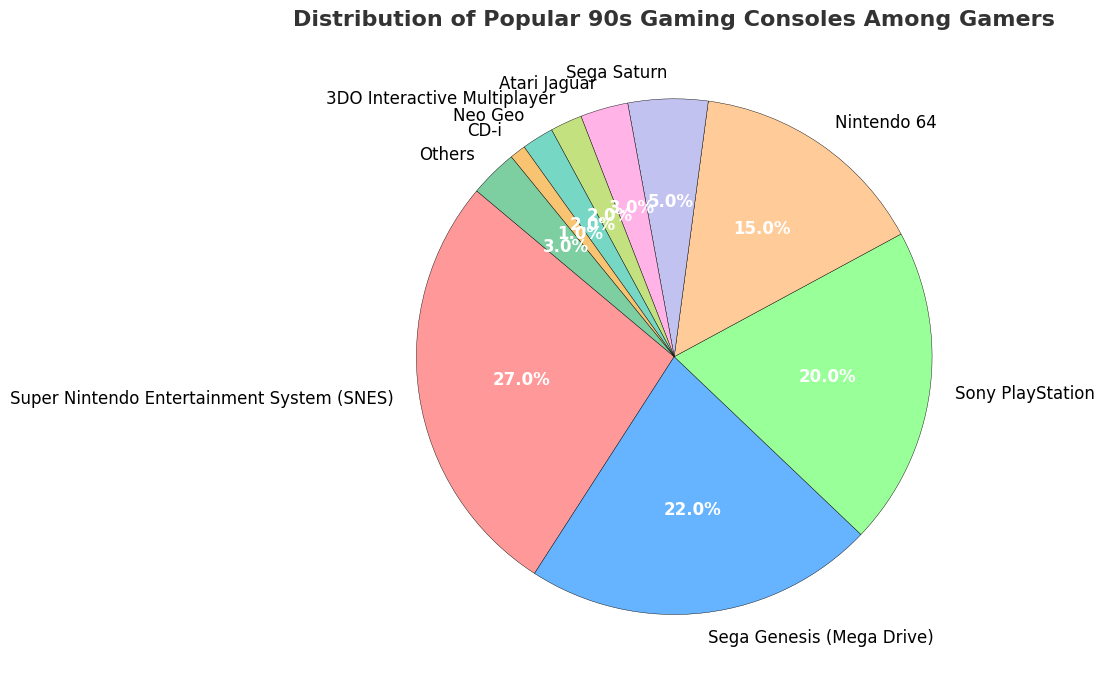Which console has the largest share among gamers? To determine the console with the largest share, look at the percentages on the pie chart; the SNES has the highest at 27%.
Answer: Super Nintendo Entertainment System (SNES) Which console has the smallest share among gamers? From the pie chart, identify the smallest segment by percentage, which is the CD-i at 1%.
Answer: CD-i How many consoles make up less than 5% each of the total distribution? Look for segments with less than 5% in the pie chart: Sega Saturn (5%), Atari Jaguar (3%), 3DO Interactive Multiplayer (2%), Neo Geo (2%), CD-i (1%), and Others (3%) which include 4 consoles.
Answer: 5 consoles Combine the shares of Sega Genesis and Sony PlayStation. What percentage do they make up together? Add the percentages for Sega Genesis (22%) and Sony PlayStation (20%): 22% + 20% = 42%.
Answer: 42% Compare the percentages of SNES and Sega Genesis in the figure. How much more percentage does SNES have? Subtract the percentage of Sega Genesis (22%) from SNES (27%): 27% - 22% = 5%.
Answer: 5% What is the combined percentage of all Nintendo consoles (SNES and Nintendo 64)? Add the percentages for SNES (27%) and Nintendo 64 (15%): 27% + 15% = 42%.
Answer: 42% Are there more gamers with Sega consoles (Genesis and Saturn) or Sony consoles (PlayStation)? Sum the percentages of Sega consoles (Genesis: 22%, Saturn: 5%) and Sony console (PlayStation: 20%): Sega = 22% + 5% = 27%, Sony = 20%. Sega has a higher percentage.
Answer: Sega consoles What is the total percentage of "Others" combined with Neo Geo and CD-i? Sum the percentages for Others (3%), Neo Geo (2%), and CD-i (1%): 3% + 2% + 1% = 6%.
Answer: 6% Which console segment appears larger visually: Sega Saturn or Atari Jaguar? By visual inspection, Sega Saturn (5%) is larger than Atari Jaguar (3%) in the pie chart.
Answer: Sega Saturn 